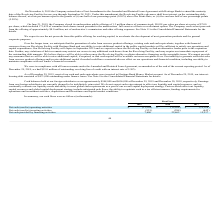From Quicklogic Corporation's financial document, What are the respective net cash used in operating activities in 2017 and 2018? The document shows two values: 12,938 and 12,638 (in thousands). From the document: "in) operating activities $ (11,594) $ (12,638) $ (12,938) cash (used in) operating activities $ (11,594) $ (12,638) $ (12,938)..." Also, What are the respective net cash used in operating activities in 2018 and 2019? The document shows two values: 12,638 and 11,594 (in thousands). From the document: "cash (used in) operating activities $ (11,594) $ (12,638) $ (12,938) Net cash (used in) operating activities $ (11,594) $ (12,638) $ (12,938)..." Also, What are the respective net cash used in investing activities in 2017 and 2018? The document shows two values: 642 and 288 (in thousands). From the document: "ash (used in) investing activities (921 ) (288 ) (642 ) Net cash (used in) investing activities (921 ) (288 ) (642 )..." Also, can you calculate: What is the total net cash used in operating activities in 2017 and 2018? Based on the calculation: (12,938 + 12,638), the result is 25576 (in thousands). This is based on the information: "in) operating activities $ (11,594) $ (12,638) $ (12,938) cash (used in) operating activities $ (11,594) $ (12,638) $ (12,938)..." The key data points involved are: 12,638, 12,938. Also, can you calculate: What is the average net cash used in operating activities in 2017 and 2018? To answer this question, I need to perform calculations using the financial data. The calculation is: (12,938 + 12,638)/2 , which equals 12788 (in thousands). This is based on the information: "in) operating activities $ (11,594) $ (12,638) $ (12,938) cash (used in) operating activities $ (11,594) $ (12,638) $ (12,938)..." The key data points involved are: 12,638, 12,938. Also, can you calculate: What is the value of the net cash used in investing activities in 2017 as a percentage of the net cash used in investing activities in 2019? Based on the calculation: 642/921 , the result is 69.71 (percentage). This is based on the information: "Net cash (used in) investing activities (921 ) (288 ) (642 ) ash (used in) investing activities (921 ) (288 ) (642 )..." The key data points involved are: 642, 921. 